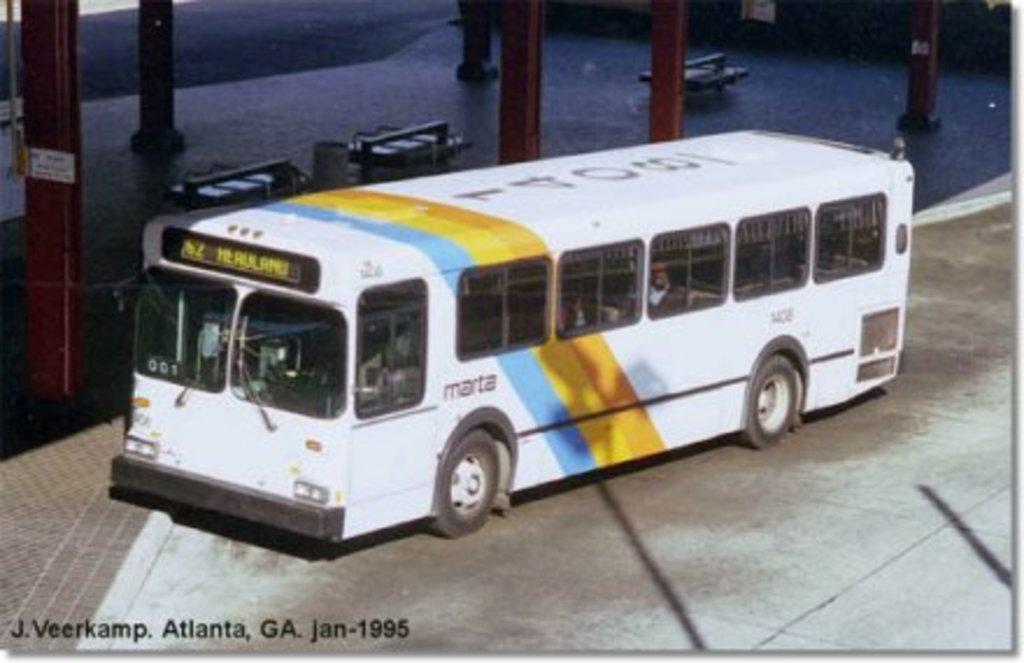What type of surface can be seen in the image? There is ground visible in the image. What mode of transportation is present in the image? There is a bus in the image. What colors are used to paint the bus? The bus is white, orange, yellow, blue, and black in color. What architectural feature can be seen in the image? There are red-colored pillars in the image. What other objects are present in the image besides the bus and pillars? There are other objects present in the image. Can you tell me how many volleyballs are being played with in the image? There are no volleyballs present in the image. What type of structure is being illuminated by the bulb in the image? There is no bulb present in the image. 